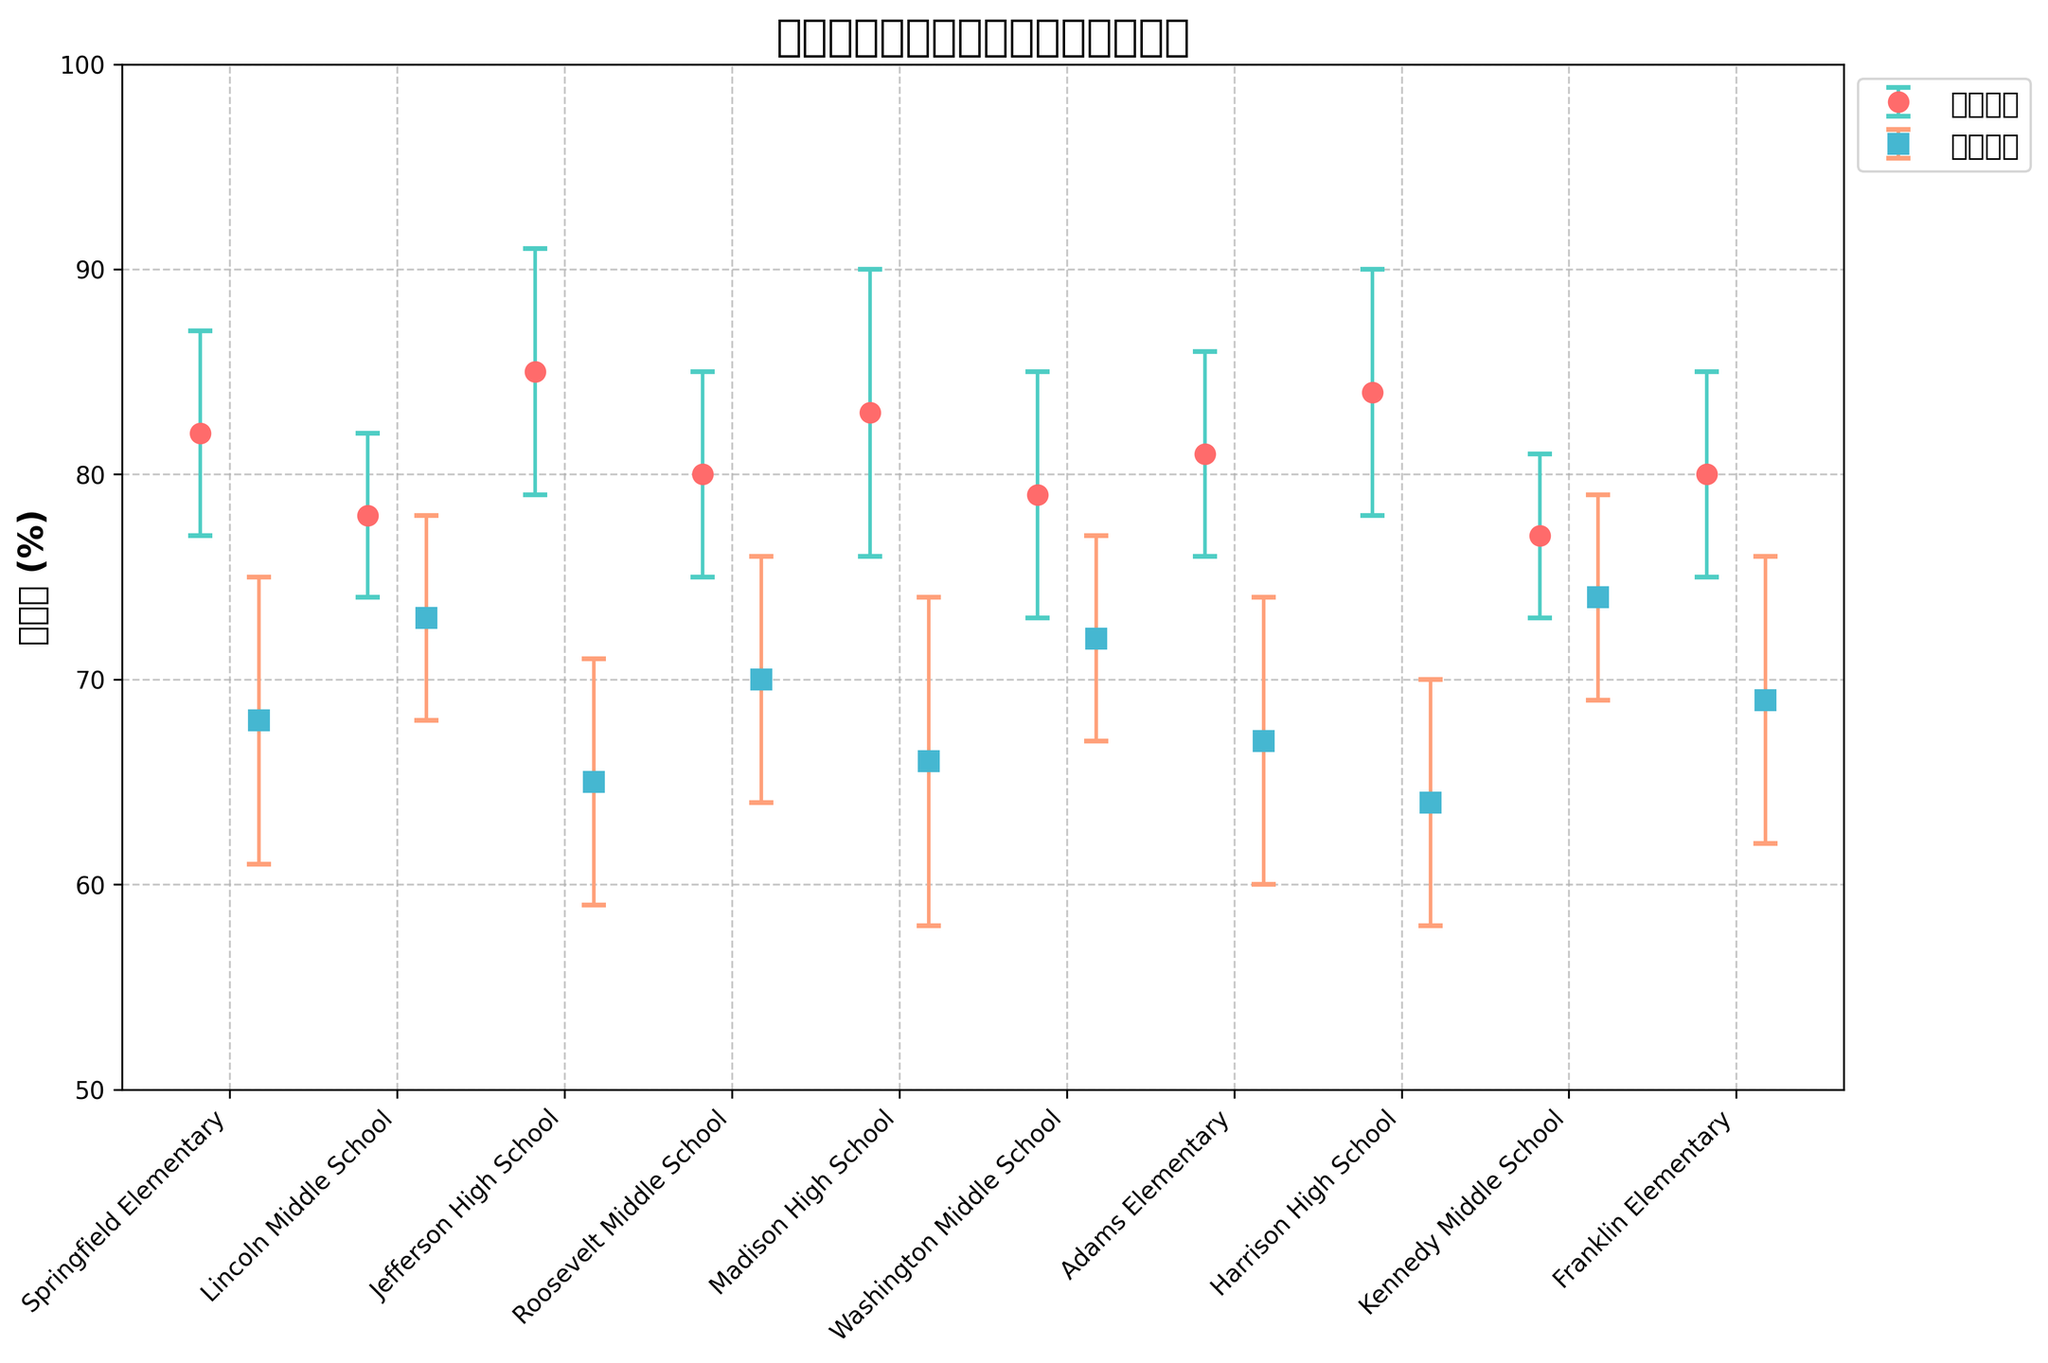what is the title of the plot? The title of the plot is always displayed at the top of the figure in a larger and bold font to convey the main information the figure is depicting.
Answer: 美国学校中华裔移民儿童的语言能力 What colors are used for Proficiency in English and Native Language Maintenance? The colors can be observed directly from the markers in the figure; Proficiency in English is represented in a reddish hue, while Native Language Maintenance is shown in a bluish hue.
Answer: 红色和蓝色 How many schools are represented in the plot? By counting the number of xticks or markers along the x-axis, we can determine the number of schools
Answer: 10 Which school has the highest mean proficiency in English? To find this, compare the heights of the red dots representing English proficiency means. The highest dot indicates the highest mean proficiency.
Answer: Jefferson High School Which school has the smallest standard deviation for Native Language Maintenance? The standard deviations are represented by the error bars. The shortest error bar among the blue squares indicates the smallest standard deviation for Native Language Maintenance.
Answer: Kennedy Middle School What is the mean proficiency in English for Roosevelt Middle School? By locating Roosevelt Middle School on the x-axis and tracing up to the corresponding red dot, we can see the mean proficiency in English.
Answer: 80% What is the average mean proficiency in English for all schools? Sum up the mean proficiency in English percentages for all schools and divide by the number of schools to find the average. (82+78+85+80+83+79+81+84+77+80)/10
Answer: 80.9% Which school has the largest difference in standard deviations between Proficiency in English and Native Language Maintenance? For each school, subtract the standard deviation of Proficiency in English from the standard deviation of Native Language Maintenance. The school with the largest resulting value has the largest difference.
Answer: Madison High School Which middle school has the better balance between Proficiency in English and Native Language Maintenance? By comparing the mean values and standard deviations of both measures for each middle school, we can judge the balance based on proximity to each other and similar error bar lengths.
Answer: Roosevelt Middle School What are the error bars depicting on the plot? Error bars represent the standard deviations around the mean values, giving a sense of the variability in the data for both English proficiency and native language maintenance.
Answer: 标准差 